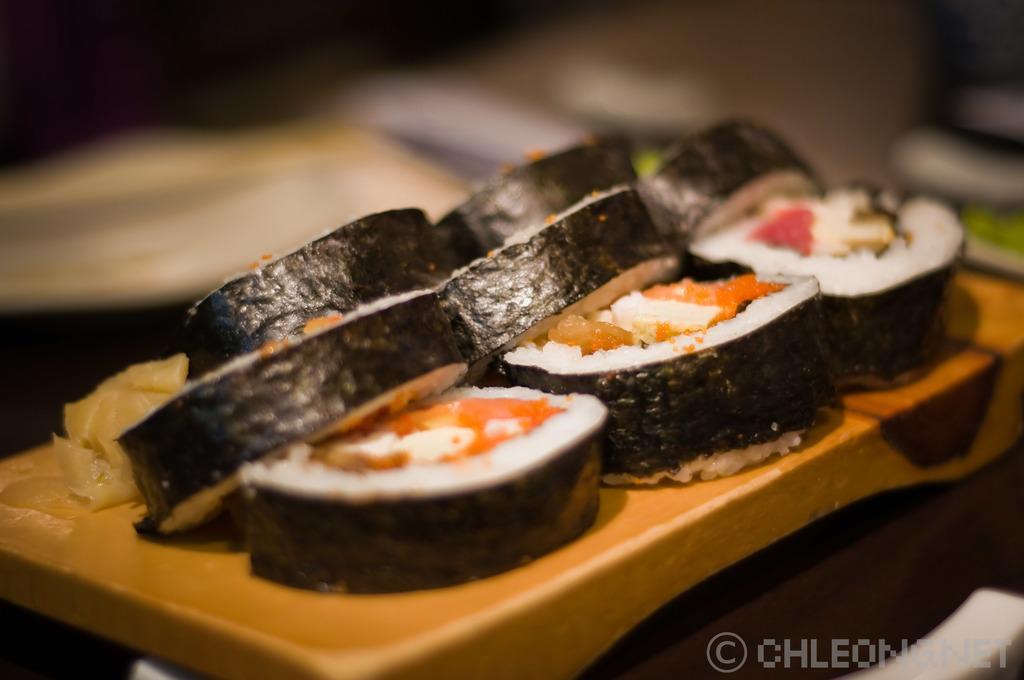Describe this image in one or two sentences. In this picture I can see the cucumber pieces and tomato pieces which are kept on the tray. At the bottom there is a table. In the bottom right corner I can see the watermark and chair. At the top I can see the blur image. 